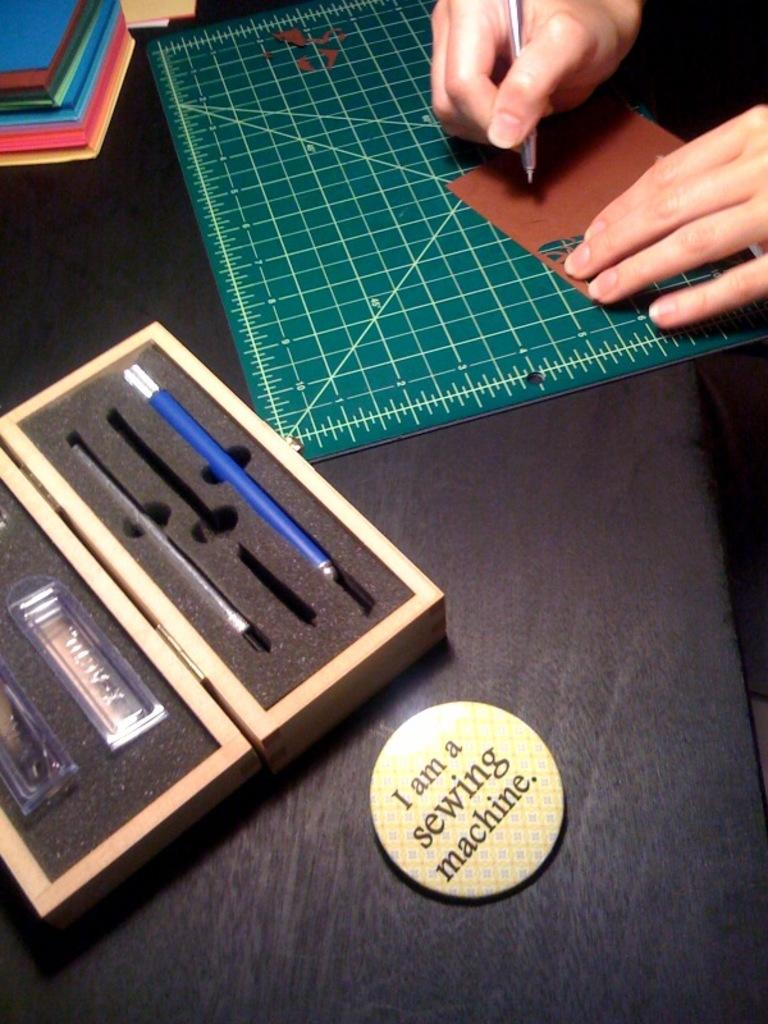<image>
Render a clear and concise summary of the photo. A person using an xacto knife on a mat with a round button in front that says I am a sewing machine. 